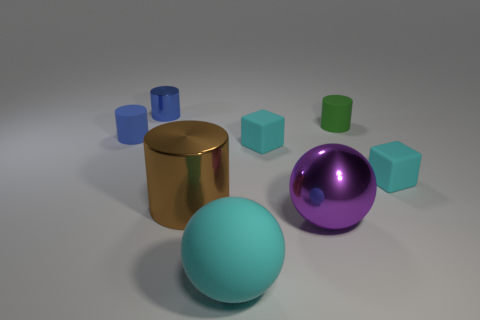Are there fewer tiny metal cylinders that are right of the tiny blue metallic object than large shiny cylinders behind the large cyan ball?
Provide a short and direct response. Yes. What number of other objects are the same shape as the large cyan object?
Your response must be concise. 1. Is the number of rubber things to the right of the big cyan object less than the number of purple balls?
Your answer should be very brief. No. What is the large object right of the large cyan rubber ball made of?
Provide a short and direct response. Metal. How many other objects are the same size as the blue matte thing?
Give a very brief answer. 4. Is the number of big shiny cylinders less than the number of big metallic blocks?
Your answer should be very brief. No. The small green thing is what shape?
Offer a terse response. Cylinder. There is a block that is left of the metallic sphere; is its color the same as the big rubber object?
Your answer should be compact. Yes. What is the shape of the object that is both on the right side of the metallic ball and in front of the tiny green rubber object?
Give a very brief answer. Cube. There is a shiny cylinder that is right of the blue metal cylinder; what color is it?
Make the answer very short. Brown. 